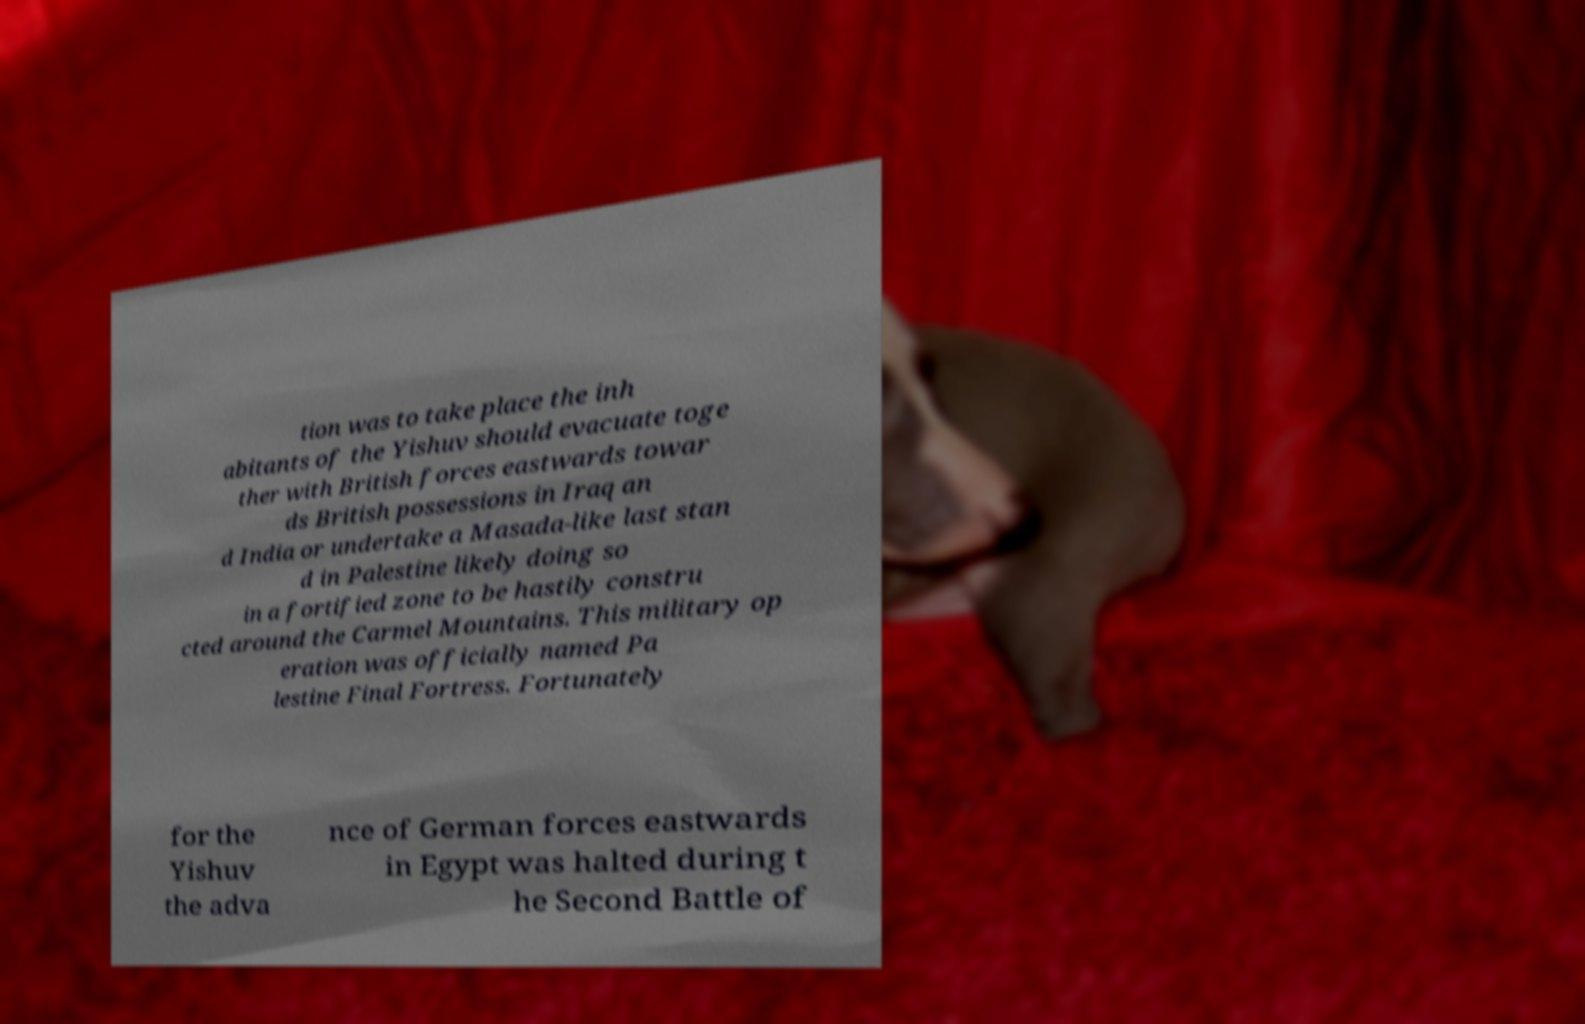Please read and relay the text visible in this image. What does it say? tion was to take place the inh abitants of the Yishuv should evacuate toge ther with British forces eastwards towar ds British possessions in Iraq an d India or undertake a Masada-like last stan d in Palestine likely doing so in a fortified zone to be hastily constru cted around the Carmel Mountains. This military op eration was officially named Pa lestine Final Fortress. Fortunately for the Yishuv the adva nce of German forces eastwards in Egypt was halted during t he Second Battle of 